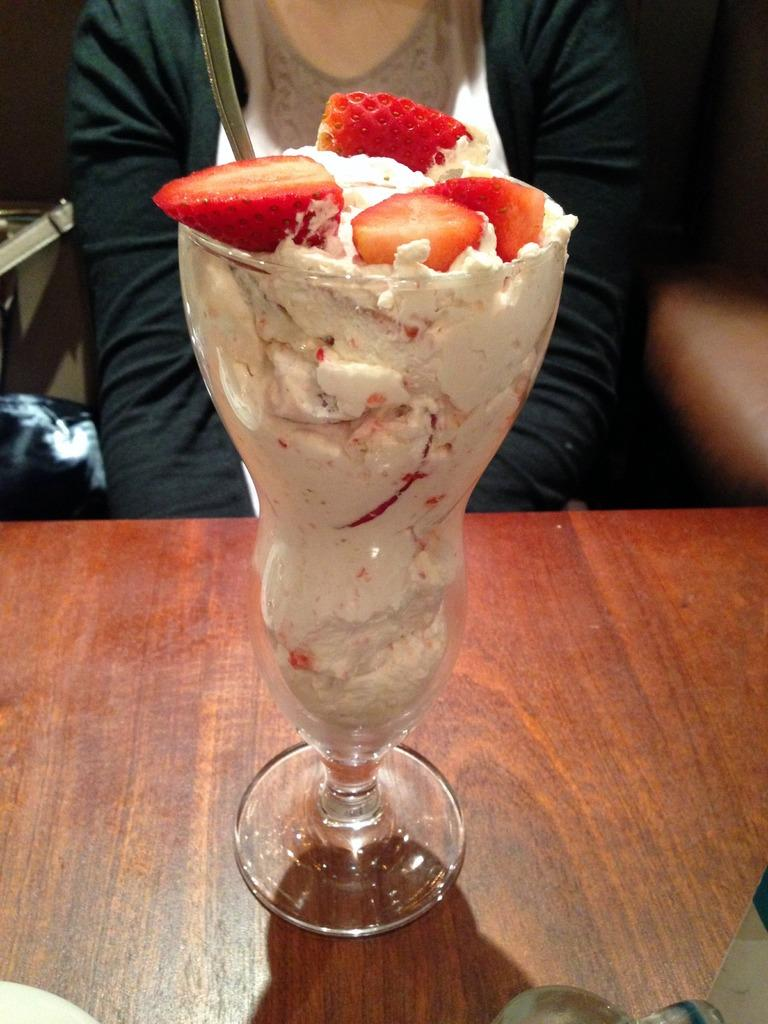What is inside the glass that is visible in the image? There is a food item in the glass that is visible in the image. Where is the glass located in the image? The glass is on a table in the image. Can you describe the person in the image? There is a person sitting in the image. What else can be seen in the image besides the glass and the person? There are objects present in the image. What type of toys can be seen on the chin of the person in the image? There are no toys visible in the image, nor are there any toys on the person's chin. 